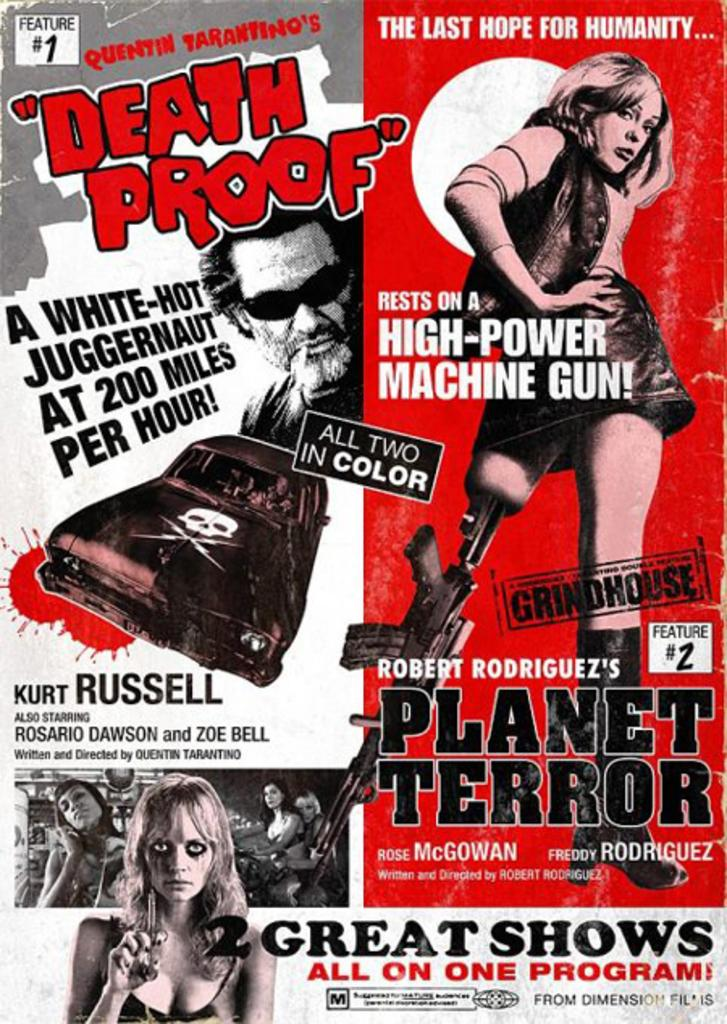What type of page is shown in the image? The image is a cover page of a book. Who are the people in the image? There is a girl and a boy in the image. What else can be seen in the image besides the people? There are objects in the image. What is the process of digestion like for the girl in the image? There is no information about the girl's digestion in the image, as it focuses on the cover page of a book. How many boys are present in the image? The image only shows one boy, not a fifth boy. 